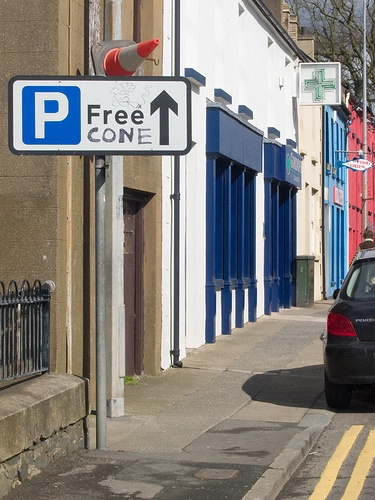Describe the objects in this image and their specific colors. I can see a car in gray, black, maroon, and darkgray tones in this image. 